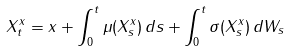Convert formula to latex. <formula><loc_0><loc_0><loc_500><loc_500>X ^ { x } _ { t } = x + \int _ { 0 } ^ { t } \mu ( X ^ { x } _ { s } ) \, d s + \int _ { 0 } ^ { t } \sigma ( X ^ { x } _ { s } ) \, d W _ { s }</formula> 